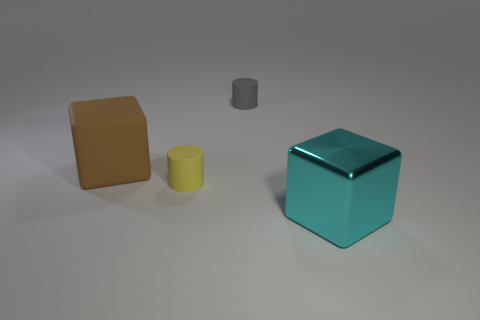Add 4 large green objects. How many objects exist? 8 Add 3 matte cubes. How many matte cubes exist? 4 Subtract 1 cyan blocks. How many objects are left? 3 Subtract all large rubber blocks. Subtract all tiny gray matte things. How many objects are left? 2 Add 1 large brown cubes. How many large brown cubes are left? 2 